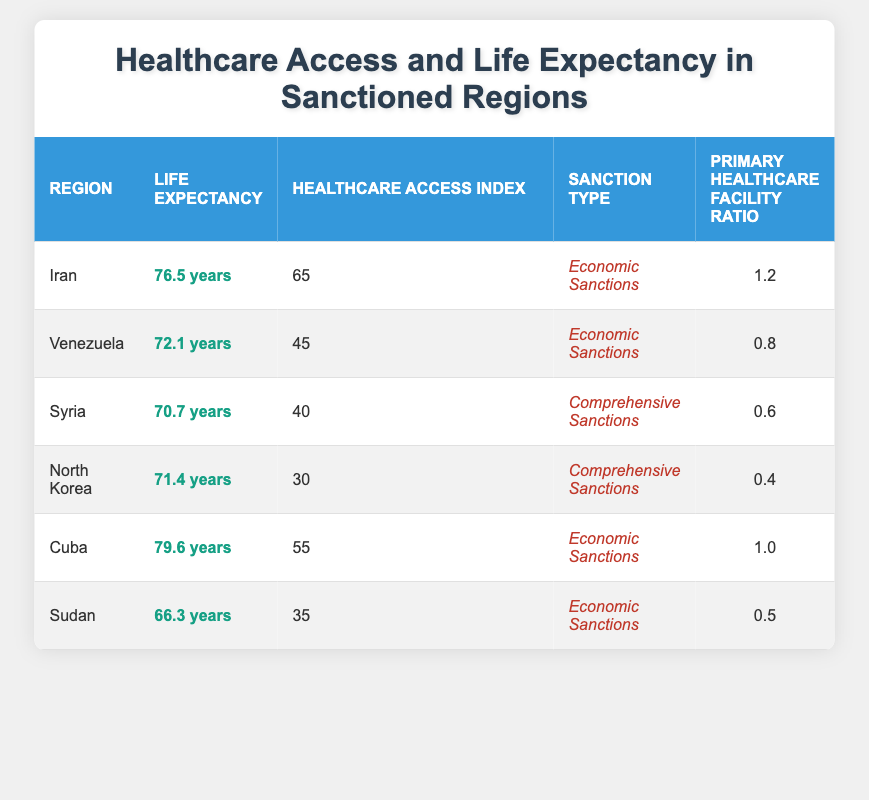What is the life expectancy in Iran? The life expectancy listed for Iran in the table is clearly stated as 76.5 years.
Answer: 76.5 years Which region has the highest healthcare access index? By examining the healthcare access index for all regions, Iran has the highest value at 65, compared to other regions listed.
Answer: Iran What is the life expectancy difference between Cuba and Venezuela? The life expectancy for Cuba is 79.6 years, and for Venezuela, it is 72.1 years. The difference is calculated as 79.6 - 72.1 = 7.5 years.
Answer: 7.5 years Is life expectancy in Syria greater than Libya? Libya is not present in the table, so a comparison cannot be made. However, the life expectancy listed for Syria is 70.7 years.
Answer: No (comparison not possible) If sanctions were lifted, what is the expected healthcare access index for the average region from the table? The average healthcare access index can be calculated by summing the indices (65 + 45 + 40 + 30 + 55 + 35) = 270 and dividing by 6 (the number of regions) gives an average of 45.
Answer: 45 Which region has the lowest primary healthcare facility ratio, and what is that value? The primary healthcare facility ratio for North Korea is the lowest at 0.4, as observed in the table.
Answer: 0.4 Do all regions under economic sanctions have a life expectancy above 70 years? Examining the life expectancies: Iran (76.5), Venezuela (72.1), and Sudan (66.3), it’s clear that not all meet the criterion, as Sudan has a life expectancy below 70 years.
Answer: No What is the correlation between primary healthcare facility ratios and life expectancy for the regions listed? Analyzing the data: higher primary healthcare facility ratios generally correlate with higher life expectancy (E.g., Iran and Cuba). However, further statistical analysis would be necessary to determine the precise correlation.
Answer: Positive correlation (general trend) What is the total life expectancy of all regions combined? By adding each region's life expectancy together (76.5 + 72.1 + 70.7 + 71.4 + 79.6 + 66.3), the total sums to 436.6 years, providing the combined life expectancy for these regions.
Answer: 436.6 years 